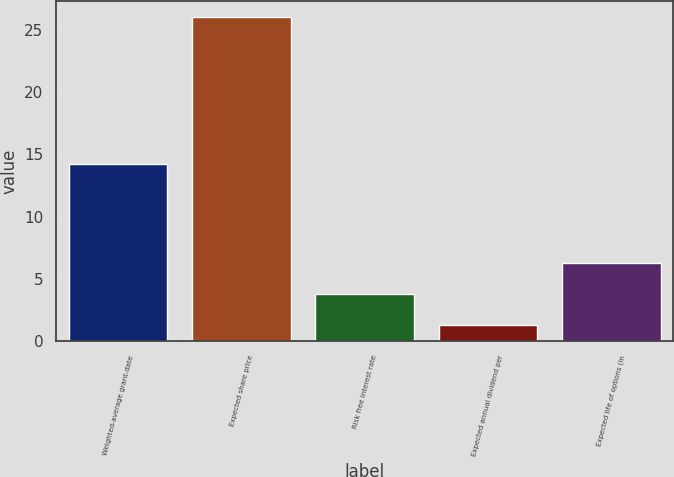Convert chart to OTSL. <chart><loc_0><loc_0><loc_500><loc_500><bar_chart><fcel>Weighted-average grant-date<fcel>Expected share price<fcel>Risk free interest rate<fcel>Expected annual dividend per<fcel>Expected life of options (in<nl><fcel>14.26<fcel>26<fcel>3.79<fcel>1.32<fcel>6.26<nl></chart> 